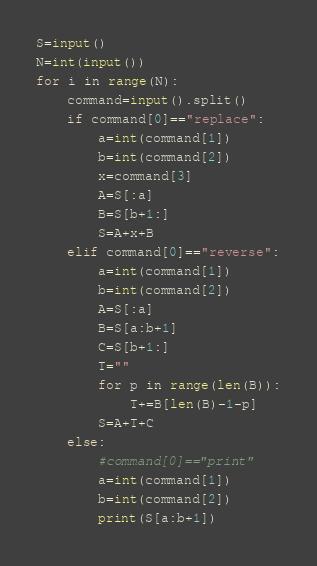Convert code to text. <code><loc_0><loc_0><loc_500><loc_500><_Python_>S=input()
N=int(input())
for i in range(N):
    command=input().split()
    if command[0]=="replace":
        a=int(command[1])
        b=int(command[2])
        x=command[3]
        A=S[:a]
        B=S[b+1:]
        S=A+x+B
    elif command[0]=="reverse":
        a=int(command[1])
        b=int(command[2])
        A=S[:a]
        B=S[a:b+1]
        C=S[b+1:]
        T=""
        for p in range(len(B)):
            T+=B[len(B)-1-p]
        S=A+T+C
    else:
        #command[0]=="print"
        a=int(command[1])
        b=int(command[2])
        print(S[a:b+1])

</code> 